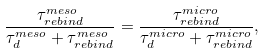<formula> <loc_0><loc_0><loc_500><loc_500>\frac { \tau _ { r e b i n d } ^ { m e s o } } { \tau _ { d } ^ { m e s o } + \tau _ { r e b i n d } ^ { m e s o } } = \frac { \tau _ { r e b i n d } ^ { m i c r o } } { \tau _ { d } ^ { m i c r o } + \tau _ { r e b i n d } ^ { m i c r o } } ,</formula> 